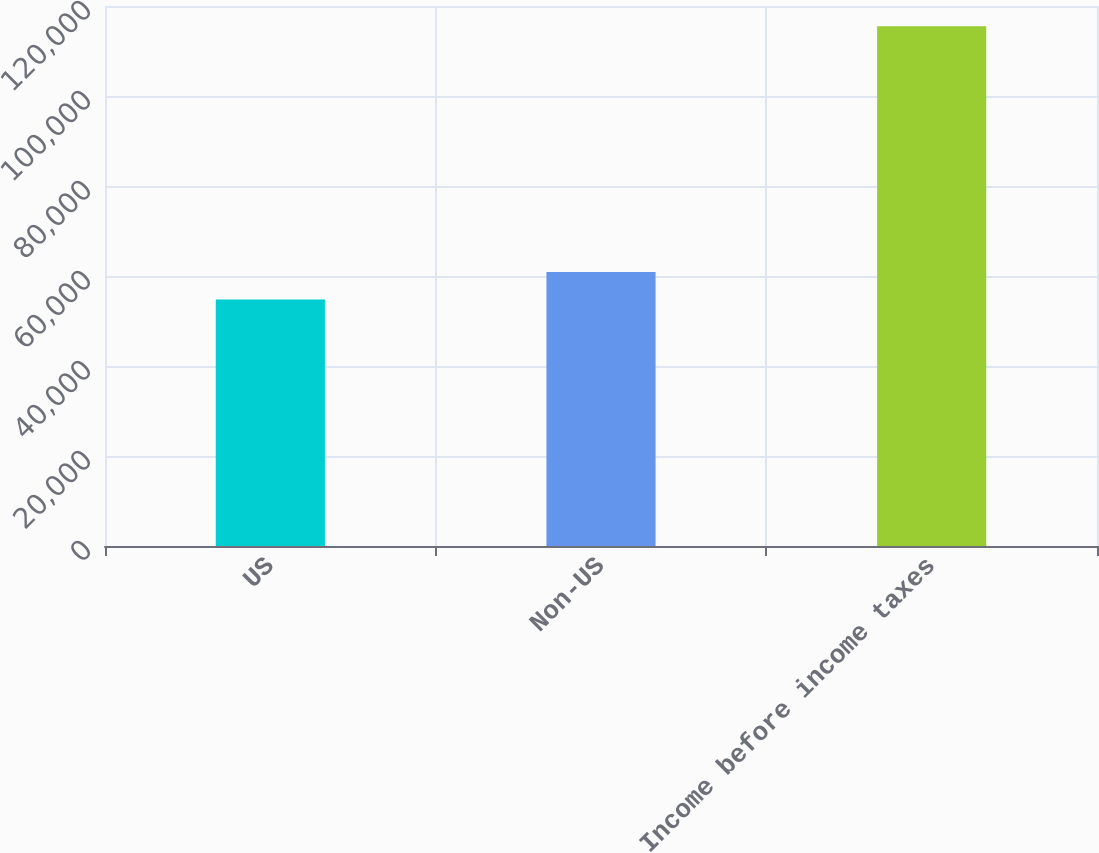<chart> <loc_0><loc_0><loc_500><loc_500><bar_chart><fcel>US<fcel>Non-US<fcel>Income before income taxes<nl><fcel>54793<fcel>60866.3<fcel>115526<nl></chart> 